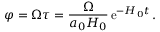Convert formula to latex. <formula><loc_0><loc_0><loc_500><loc_500>\varphi = \Omega \tau = \frac { \Omega } { a _ { 0 } H _ { 0 } } \, e ^ { - H _ { 0 } t } \, .</formula> 